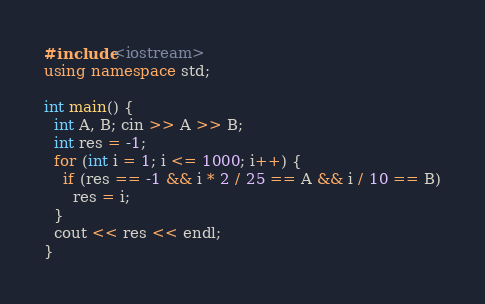<code> <loc_0><loc_0><loc_500><loc_500><_C++_>#include<iostream>
using namespace std;

int main() {
  int A, B; cin >> A >> B;
  int res = -1;
  for (int i = 1; i <= 1000; i++) {
    if (res == -1 && i * 2 / 25 == A && i / 10 == B)
      res = i;
  }
  cout << res << endl;
}</code> 